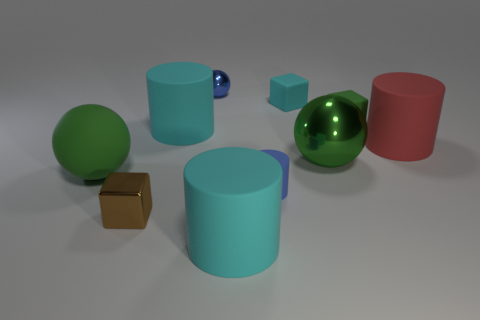What materials are the objects in the image made of? The objects appear to be made of different materials. One is metallic, and the others look like they could be plastic or ceramic, judging by their matte and glossy surfaces. Which object stands out the most to you? The metallic object stands out due to its unique reflective surface in contrast with the other objects. 